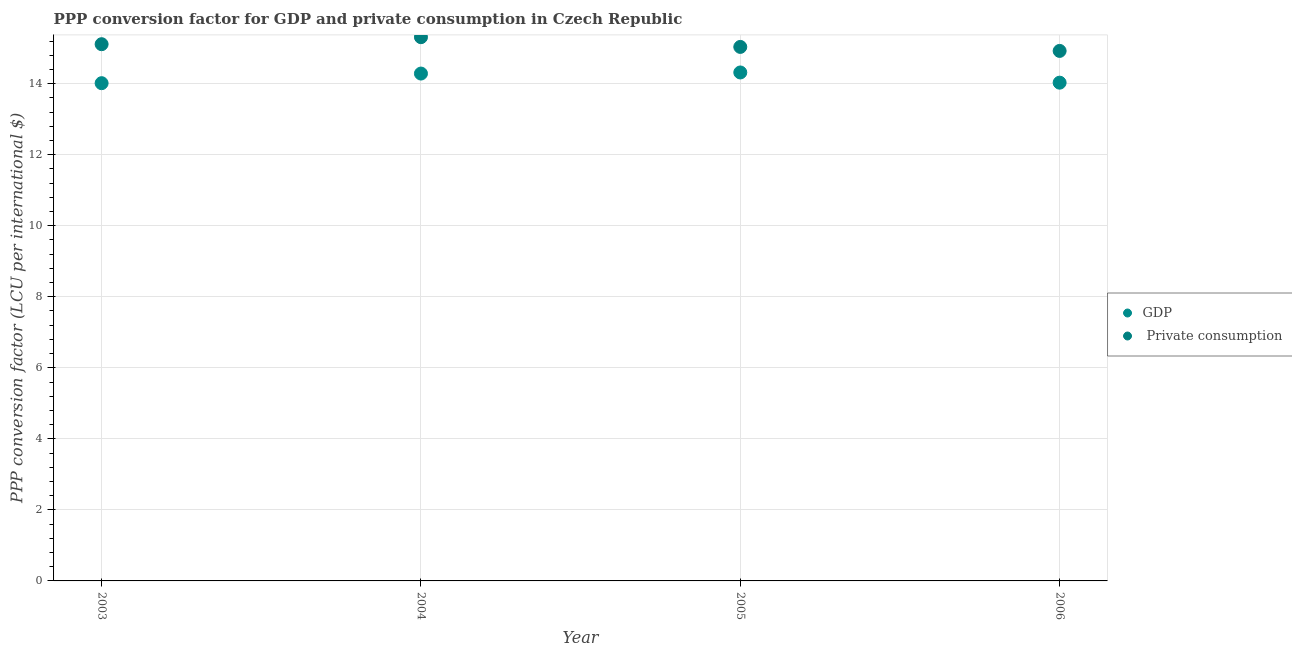How many different coloured dotlines are there?
Provide a short and direct response. 2. What is the ppp conversion factor for gdp in 2004?
Keep it short and to the point. 14.29. Across all years, what is the maximum ppp conversion factor for gdp?
Ensure brevity in your answer.  14.32. Across all years, what is the minimum ppp conversion factor for gdp?
Provide a short and direct response. 14.01. In which year was the ppp conversion factor for private consumption maximum?
Your response must be concise. 2004. In which year was the ppp conversion factor for private consumption minimum?
Offer a terse response. 2006. What is the total ppp conversion factor for gdp in the graph?
Provide a short and direct response. 56.65. What is the difference between the ppp conversion factor for gdp in 2004 and that in 2006?
Your response must be concise. 0.26. What is the difference between the ppp conversion factor for gdp in 2006 and the ppp conversion factor for private consumption in 2004?
Offer a terse response. -1.28. What is the average ppp conversion factor for gdp per year?
Provide a succinct answer. 14.16. In the year 2003, what is the difference between the ppp conversion factor for gdp and ppp conversion factor for private consumption?
Offer a very short reply. -1.1. What is the ratio of the ppp conversion factor for private consumption in 2003 to that in 2004?
Offer a very short reply. 0.99. Is the difference between the ppp conversion factor for gdp in 2005 and 2006 greater than the difference between the ppp conversion factor for private consumption in 2005 and 2006?
Keep it short and to the point. Yes. What is the difference between the highest and the second highest ppp conversion factor for gdp?
Your response must be concise. 0.03. What is the difference between the highest and the lowest ppp conversion factor for gdp?
Offer a very short reply. 0.3. Is the ppp conversion factor for gdp strictly less than the ppp conversion factor for private consumption over the years?
Offer a terse response. Yes. How many years are there in the graph?
Your answer should be very brief. 4. What is the difference between two consecutive major ticks on the Y-axis?
Give a very brief answer. 2. Are the values on the major ticks of Y-axis written in scientific E-notation?
Provide a short and direct response. No. Does the graph contain any zero values?
Your answer should be very brief. No. Does the graph contain grids?
Make the answer very short. Yes. Where does the legend appear in the graph?
Make the answer very short. Center right. How many legend labels are there?
Your answer should be compact. 2. How are the legend labels stacked?
Your answer should be very brief. Vertical. What is the title of the graph?
Keep it short and to the point. PPP conversion factor for GDP and private consumption in Czech Republic. Does "Mobile cellular" appear as one of the legend labels in the graph?
Offer a terse response. No. What is the label or title of the Y-axis?
Provide a short and direct response. PPP conversion factor (LCU per international $). What is the PPP conversion factor (LCU per international $) of GDP in 2003?
Give a very brief answer. 14.01. What is the PPP conversion factor (LCU per international $) of  Private consumption in 2003?
Your answer should be very brief. 15.11. What is the PPP conversion factor (LCU per international $) in GDP in 2004?
Keep it short and to the point. 14.29. What is the PPP conversion factor (LCU per international $) of  Private consumption in 2004?
Ensure brevity in your answer.  15.31. What is the PPP conversion factor (LCU per international $) in GDP in 2005?
Provide a succinct answer. 14.32. What is the PPP conversion factor (LCU per international $) in  Private consumption in 2005?
Ensure brevity in your answer.  15.04. What is the PPP conversion factor (LCU per international $) in GDP in 2006?
Your answer should be very brief. 14.03. What is the PPP conversion factor (LCU per international $) of  Private consumption in 2006?
Your answer should be compact. 14.92. Across all years, what is the maximum PPP conversion factor (LCU per international $) in GDP?
Provide a succinct answer. 14.32. Across all years, what is the maximum PPP conversion factor (LCU per international $) in  Private consumption?
Offer a terse response. 15.31. Across all years, what is the minimum PPP conversion factor (LCU per international $) in GDP?
Provide a succinct answer. 14.01. Across all years, what is the minimum PPP conversion factor (LCU per international $) of  Private consumption?
Offer a very short reply. 14.92. What is the total PPP conversion factor (LCU per international $) in GDP in the graph?
Provide a short and direct response. 56.65. What is the total PPP conversion factor (LCU per international $) in  Private consumption in the graph?
Your response must be concise. 60.38. What is the difference between the PPP conversion factor (LCU per international $) of GDP in 2003 and that in 2004?
Ensure brevity in your answer.  -0.27. What is the difference between the PPP conversion factor (LCU per international $) in  Private consumption in 2003 and that in 2004?
Your answer should be very brief. -0.2. What is the difference between the PPP conversion factor (LCU per international $) in GDP in 2003 and that in 2005?
Your answer should be compact. -0.3. What is the difference between the PPP conversion factor (LCU per international $) in  Private consumption in 2003 and that in 2005?
Provide a short and direct response. 0.08. What is the difference between the PPP conversion factor (LCU per international $) of GDP in 2003 and that in 2006?
Keep it short and to the point. -0.01. What is the difference between the PPP conversion factor (LCU per international $) in  Private consumption in 2003 and that in 2006?
Keep it short and to the point. 0.19. What is the difference between the PPP conversion factor (LCU per international $) of GDP in 2004 and that in 2005?
Offer a very short reply. -0.03. What is the difference between the PPP conversion factor (LCU per international $) of  Private consumption in 2004 and that in 2005?
Make the answer very short. 0.27. What is the difference between the PPP conversion factor (LCU per international $) in GDP in 2004 and that in 2006?
Your answer should be compact. 0.26. What is the difference between the PPP conversion factor (LCU per international $) in  Private consumption in 2004 and that in 2006?
Ensure brevity in your answer.  0.39. What is the difference between the PPP conversion factor (LCU per international $) in GDP in 2005 and that in 2006?
Make the answer very short. 0.29. What is the difference between the PPP conversion factor (LCU per international $) in  Private consumption in 2005 and that in 2006?
Make the answer very short. 0.11. What is the difference between the PPP conversion factor (LCU per international $) of GDP in 2003 and the PPP conversion factor (LCU per international $) of  Private consumption in 2004?
Your answer should be very brief. -1.3. What is the difference between the PPP conversion factor (LCU per international $) in GDP in 2003 and the PPP conversion factor (LCU per international $) in  Private consumption in 2005?
Your response must be concise. -1.02. What is the difference between the PPP conversion factor (LCU per international $) in GDP in 2003 and the PPP conversion factor (LCU per international $) in  Private consumption in 2006?
Provide a short and direct response. -0.91. What is the difference between the PPP conversion factor (LCU per international $) of GDP in 2004 and the PPP conversion factor (LCU per international $) of  Private consumption in 2005?
Make the answer very short. -0.75. What is the difference between the PPP conversion factor (LCU per international $) in GDP in 2004 and the PPP conversion factor (LCU per international $) in  Private consumption in 2006?
Give a very brief answer. -0.64. What is the difference between the PPP conversion factor (LCU per international $) in GDP in 2005 and the PPP conversion factor (LCU per international $) in  Private consumption in 2006?
Offer a terse response. -0.61. What is the average PPP conversion factor (LCU per international $) of GDP per year?
Ensure brevity in your answer.  14.16. What is the average PPP conversion factor (LCU per international $) in  Private consumption per year?
Provide a succinct answer. 15.1. In the year 2003, what is the difference between the PPP conversion factor (LCU per international $) of GDP and PPP conversion factor (LCU per international $) of  Private consumption?
Your response must be concise. -1.1. In the year 2004, what is the difference between the PPP conversion factor (LCU per international $) in GDP and PPP conversion factor (LCU per international $) in  Private consumption?
Provide a short and direct response. -1.02. In the year 2005, what is the difference between the PPP conversion factor (LCU per international $) in GDP and PPP conversion factor (LCU per international $) in  Private consumption?
Your response must be concise. -0.72. In the year 2006, what is the difference between the PPP conversion factor (LCU per international $) of GDP and PPP conversion factor (LCU per international $) of  Private consumption?
Your answer should be compact. -0.89. What is the ratio of the PPP conversion factor (LCU per international $) in  Private consumption in 2003 to that in 2004?
Your answer should be very brief. 0.99. What is the ratio of the PPP conversion factor (LCU per international $) of GDP in 2003 to that in 2005?
Provide a short and direct response. 0.98. What is the ratio of the PPP conversion factor (LCU per international $) of GDP in 2003 to that in 2006?
Give a very brief answer. 1. What is the ratio of the PPP conversion factor (LCU per international $) of  Private consumption in 2003 to that in 2006?
Provide a short and direct response. 1.01. What is the ratio of the PPP conversion factor (LCU per international $) of GDP in 2004 to that in 2005?
Offer a very short reply. 1. What is the ratio of the PPP conversion factor (LCU per international $) of  Private consumption in 2004 to that in 2005?
Provide a short and direct response. 1.02. What is the ratio of the PPP conversion factor (LCU per international $) in GDP in 2004 to that in 2006?
Ensure brevity in your answer.  1.02. What is the ratio of the PPP conversion factor (LCU per international $) in  Private consumption in 2004 to that in 2006?
Offer a terse response. 1.03. What is the ratio of the PPP conversion factor (LCU per international $) of GDP in 2005 to that in 2006?
Provide a succinct answer. 1.02. What is the ratio of the PPP conversion factor (LCU per international $) of  Private consumption in 2005 to that in 2006?
Offer a terse response. 1.01. What is the difference between the highest and the second highest PPP conversion factor (LCU per international $) in GDP?
Your answer should be very brief. 0.03. What is the difference between the highest and the second highest PPP conversion factor (LCU per international $) in  Private consumption?
Your answer should be very brief. 0.2. What is the difference between the highest and the lowest PPP conversion factor (LCU per international $) in GDP?
Your answer should be very brief. 0.3. What is the difference between the highest and the lowest PPP conversion factor (LCU per international $) in  Private consumption?
Your answer should be compact. 0.39. 